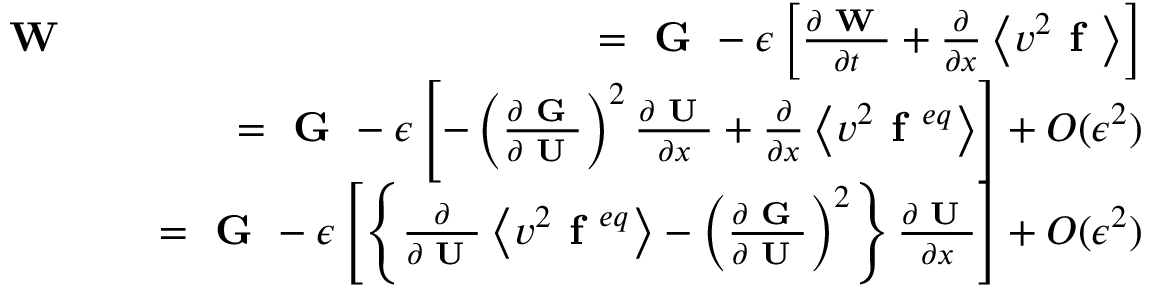Convert formula to latex. <formula><loc_0><loc_0><loc_500><loc_500>\begin{array} { r l r } { W } & { = G - \epsilon \left [ \frac { \partial W } { \partial t } + \frac { \partial } { \partial x } \left \langle v ^ { 2 } f \right \rangle \right ] } \\ & { = G - \epsilon \left [ - \left ( \frac { \partial G } { \partial U } \right ) ^ { 2 } \frac { \partial U } { \partial x } + \frac { \partial } { \partial x } \left \langle v ^ { 2 } f ^ { e q } \right \rangle \right ] + O ( \epsilon ^ { 2 } ) } \\ & { = G - \epsilon \left [ \left \{ \frac { \partial } { \partial U } \left \langle v ^ { 2 } f ^ { e q } \right \rangle - \left ( \frac { \partial G } { \partial U } \right ) ^ { 2 } \right \} \frac { \partial U } { \partial x } \right ] + O ( \epsilon ^ { 2 } ) } \end{array}</formula> 